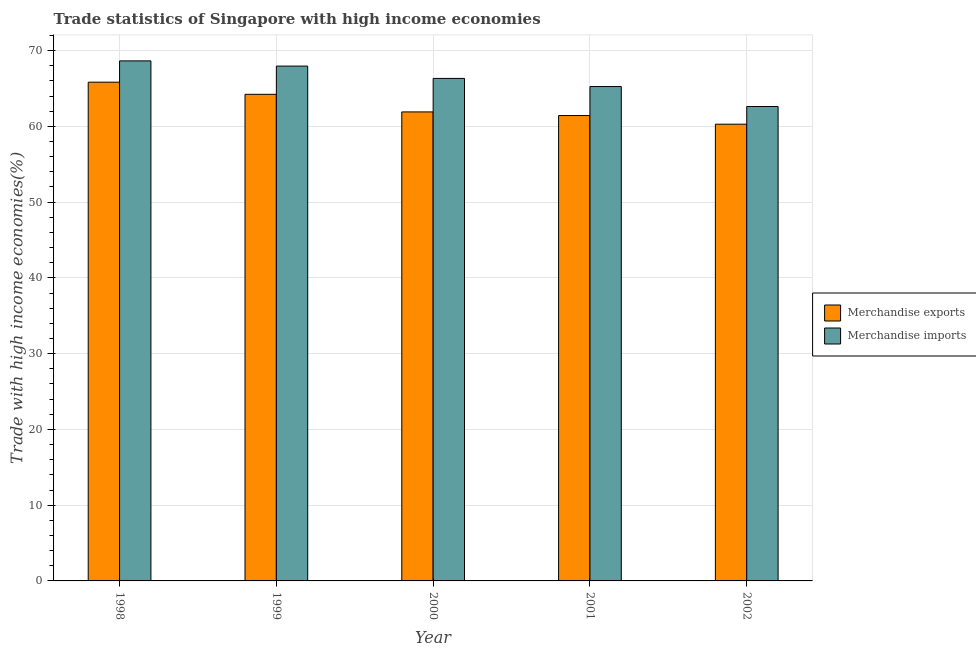How many different coloured bars are there?
Offer a terse response. 2. Are the number of bars on each tick of the X-axis equal?
Provide a succinct answer. Yes. How many bars are there on the 2nd tick from the left?
Your answer should be compact. 2. How many bars are there on the 2nd tick from the right?
Give a very brief answer. 2. In how many cases, is the number of bars for a given year not equal to the number of legend labels?
Offer a very short reply. 0. What is the merchandise imports in 2002?
Make the answer very short. 62.62. Across all years, what is the maximum merchandise exports?
Provide a short and direct response. 65.83. Across all years, what is the minimum merchandise exports?
Ensure brevity in your answer.  60.28. What is the total merchandise imports in the graph?
Offer a terse response. 330.78. What is the difference between the merchandise imports in 1998 and that in 2000?
Your response must be concise. 2.31. What is the difference between the merchandise imports in 2001 and the merchandise exports in 1998?
Offer a very short reply. -3.39. What is the average merchandise imports per year?
Offer a terse response. 66.16. What is the ratio of the merchandise exports in 1998 to that in 2000?
Provide a succinct answer. 1.06. Is the merchandise imports in 1999 less than that in 2001?
Provide a succinct answer. No. Is the difference between the merchandise exports in 1999 and 2001 greater than the difference between the merchandise imports in 1999 and 2001?
Provide a succinct answer. No. What is the difference between the highest and the second highest merchandise exports?
Offer a terse response. 1.6. What is the difference between the highest and the lowest merchandise imports?
Offer a very short reply. 6.02. In how many years, is the merchandise exports greater than the average merchandise exports taken over all years?
Offer a terse response. 2. Is the sum of the merchandise exports in 1998 and 2000 greater than the maximum merchandise imports across all years?
Keep it short and to the point. Yes. What does the 2nd bar from the left in 1999 represents?
Provide a succinct answer. Merchandise imports. What does the 1st bar from the right in 2000 represents?
Provide a short and direct response. Merchandise imports. How many bars are there?
Offer a very short reply. 10. Are all the bars in the graph horizontal?
Ensure brevity in your answer.  No. Does the graph contain any zero values?
Provide a short and direct response. No. Does the graph contain grids?
Provide a succinct answer. Yes. How are the legend labels stacked?
Offer a very short reply. Vertical. What is the title of the graph?
Give a very brief answer. Trade statistics of Singapore with high income economies. Does "Females" appear as one of the legend labels in the graph?
Give a very brief answer. No. What is the label or title of the Y-axis?
Make the answer very short. Trade with high income economies(%). What is the Trade with high income economies(%) in Merchandise exports in 1998?
Your response must be concise. 65.83. What is the Trade with high income economies(%) of Merchandise imports in 1998?
Your answer should be compact. 68.64. What is the Trade with high income economies(%) of Merchandise exports in 1999?
Offer a very short reply. 64.22. What is the Trade with high income economies(%) in Merchandise imports in 1999?
Offer a terse response. 67.95. What is the Trade with high income economies(%) of Merchandise exports in 2000?
Your answer should be compact. 61.9. What is the Trade with high income economies(%) of Merchandise imports in 2000?
Your answer should be very brief. 66.32. What is the Trade with high income economies(%) of Merchandise exports in 2001?
Offer a very short reply. 61.42. What is the Trade with high income economies(%) in Merchandise imports in 2001?
Ensure brevity in your answer.  65.25. What is the Trade with high income economies(%) in Merchandise exports in 2002?
Keep it short and to the point. 60.28. What is the Trade with high income economies(%) of Merchandise imports in 2002?
Offer a terse response. 62.62. Across all years, what is the maximum Trade with high income economies(%) in Merchandise exports?
Your response must be concise. 65.83. Across all years, what is the maximum Trade with high income economies(%) in Merchandise imports?
Provide a succinct answer. 68.64. Across all years, what is the minimum Trade with high income economies(%) of Merchandise exports?
Your answer should be compact. 60.28. Across all years, what is the minimum Trade with high income economies(%) of Merchandise imports?
Offer a terse response. 62.62. What is the total Trade with high income economies(%) in Merchandise exports in the graph?
Your answer should be compact. 313.65. What is the total Trade with high income economies(%) of Merchandise imports in the graph?
Your response must be concise. 330.78. What is the difference between the Trade with high income economies(%) in Merchandise exports in 1998 and that in 1999?
Give a very brief answer. 1.6. What is the difference between the Trade with high income economies(%) of Merchandise imports in 1998 and that in 1999?
Keep it short and to the point. 0.69. What is the difference between the Trade with high income economies(%) in Merchandise exports in 1998 and that in 2000?
Your answer should be compact. 3.93. What is the difference between the Trade with high income economies(%) of Merchandise imports in 1998 and that in 2000?
Ensure brevity in your answer.  2.31. What is the difference between the Trade with high income economies(%) in Merchandise exports in 1998 and that in 2001?
Make the answer very short. 4.41. What is the difference between the Trade with high income economies(%) of Merchandise imports in 1998 and that in 2001?
Ensure brevity in your answer.  3.39. What is the difference between the Trade with high income economies(%) in Merchandise exports in 1998 and that in 2002?
Offer a terse response. 5.55. What is the difference between the Trade with high income economies(%) in Merchandise imports in 1998 and that in 2002?
Your response must be concise. 6.02. What is the difference between the Trade with high income economies(%) of Merchandise exports in 1999 and that in 2000?
Your answer should be very brief. 2.32. What is the difference between the Trade with high income economies(%) of Merchandise imports in 1999 and that in 2000?
Your answer should be compact. 1.63. What is the difference between the Trade with high income economies(%) of Merchandise exports in 1999 and that in 2001?
Your response must be concise. 2.8. What is the difference between the Trade with high income economies(%) of Merchandise imports in 1999 and that in 2001?
Offer a very short reply. 2.7. What is the difference between the Trade with high income economies(%) in Merchandise exports in 1999 and that in 2002?
Your answer should be compact. 3.94. What is the difference between the Trade with high income economies(%) in Merchandise imports in 1999 and that in 2002?
Give a very brief answer. 5.33. What is the difference between the Trade with high income economies(%) in Merchandise exports in 2000 and that in 2001?
Ensure brevity in your answer.  0.48. What is the difference between the Trade with high income economies(%) of Merchandise imports in 2000 and that in 2001?
Keep it short and to the point. 1.07. What is the difference between the Trade with high income economies(%) in Merchandise exports in 2000 and that in 2002?
Make the answer very short. 1.62. What is the difference between the Trade with high income economies(%) in Merchandise imports in 2000 and that in 2002?
Provide a succinct answer. 3.71. What is the difference between the Trade with high income economies(%) in Merchandise exports in 2001 and that in 2002?
Make the answer very short. 1.14. What is the difference between the Trade with high income economies(%) of Merchandise imports in 2001 and that in 2002?
Ensure brevity in your answer.  2.63. What is the difference between the Trade with high income economies(%) in Merchandise exports in 1998 and the Trade with high income economies(%) in Merchandise imports in 1999?
Make the answer very short. -2.12. What is the difference between the Trade with high income economies(%) in Merchandise exports in 1998 and the Trade with high income economies(%) in Merchandise imports in 2000?
Keep it short and to the point. -0.5. What is the difference between the Trade with high income economies(%) of Merchandise exports in 1998 and the Trade with high income economies(%) of Merchandise imports in 2001?
Keep it short and to the point. 0.58. What is the difference between the Trade with high income economies(%) in Merchandise exports in 1998 and the Trade with high income economies(%) in Merchandise imports in 2002?
Make the answer very short. 3.21. What is the difference between the Trade with high income economies(%) in Merchandise exports in 1999 and the Trade with high income economies(%) in Merchandise imports in 2000?
Give a very brief answer. -2.1. What is the difference between the Trade with high income economies(%) in Merchandise exports in 1999 and the Trade with high income economies(%) in Merchandise imports in 2001?
Give a very brief answer. -1.03. What is the difference between the Trade with high income economies(%) of Merchandise exports in 1999 and the Trade with high income economies(%) of Merchandise imports in 2002?
Make the answer very short. 1.61. What is the difference between the Trade with high income economies(%) of Merchandise exports in 2000 and the Trade with high income economies(%) of Merchandise imports in 2001?
Make the answer very short. -3.35. What is the difference between the Trade with high income economies(%) of Merchandise exports in 2000 and the Trade with high income economies(%) of Merchandise imports in 2002?
Keep it short and to the point. -0.71. What is the difference between the Trade with high income economies(%) in Merchandise exports in 2001 and the Trade with high income economies(%) in Merchandise imports in 2002?
Your answer should be very brief. -1.19. What is the average Trade with high income economies(%) of Merchandise exports per year?
Provide a succinct answer. 62.73. What is the average Trade with high income economies(%) in Merchandise imports per year?
Your response must be concise. 66.16. In the year 1998, what is the difference between the Trade with high income economies(%) of Merchandise exports and Trade with high income economies(%) of Merchandise imports?
Make the answer very short. -2.81. In the year 1999, what is the difference between the Trade with high income economies(%) in Merchandise exports and Trade with high income economies(%) in Merchandise imports?
Provide a short and direct response. -3.73. In the year 2000, what is the difference between the Trade with high income economies(%) of Merchandise exports and Trade with high income economies(%) of Merchandise imports?
Ensure brevity in your answer.  -4.42. In the year 2001, what is the difference between the Trade with high income economies(%) of Merchandise exports and Trade with high income economies(%) of Merchandise imports?
Provide a succinct answer. -3.83. In the year 2002, what is the difference between the Trade with high income economies(%) of Merchandise exports and Trade with high income economies(%) of Merchandise imports?
Offer a terse response. -2.34. What is the ratio of the Trade with high income economies(%) of Merchandise exports in 1998 to that in 1999?
Keep it short and to the point. 1.02. What is the ratio of the Trade with high income economies(%) in Merchandise exports in 1998 to that in 2000?
Your answer should be very brief. 1.06. What is the ratio of the Trade with high income economies(%) of Merchandise imports in 1998 to that in 2000?
Provide a short and direct response. 1.03. What is the ratio of the Trade with high income economies(%) of Merchandise exports in 1998 to that in 2001?
Provide a short and direct response. 1.07. What is the ratio of the Trade with high income economies(%) in Merchandise imports in 1998 to that in 2001?
Ensure brevity in your answer.  1.05. What is the ratio of the Trade with high income economies(%) in Merchandise exports in 1998 to that in 2002?
Offer a very short reply. 1.09. What is the ratio of the Trade with high income economies(%) of Merchandise imports in 1998 to that in 2002?
Your response must be concise. 1.1. What is the ratio of the Trade with high income economies(%) in Merchandise exports in 1999 to that in 2000?
Your answer should be compact. 1.04. What is the ratio of the Trade with high income economies(%) in Merchandise imports in 1999 to that in 2000?
Make the answer very short. 1.02. What is the ratio of the Trade with high income economies(%) in Merchandise exports in 1999 to that in 2001?
Your answer should be very brief. 1.05. What is the ratio of the Trade with high income economies(%) of Merchandise imports in 1999 to that in 2001?
Keep it short and to the point. 1.04. What is the ratio of the Trade with high income economies(%) in Merchandise exports in 1999 to that in 2002?
Offer a very short reply. 1.07. What is the ratio of the Trade with high income economies(%) in Merchandise imports in 1999 to that in 2002?
Make the answer very short. 1.09. What is the ratio of the Trade with high income economies(%) of Merchandise imports in 2000 to that in 2001?
Provide a short and direct response. 1.02. What is the ratio of the Trade with high income economies(%) in Merchandise exports in 2000 to that in 2002?
Ensure brevity in your answer.  1.03. What is the ratio of the Trade with high income economies(%) in Merchandise imports in 2000 to that in 2002?
Offer a very short reply. 1.06. What is the ratio of the Trade with high income economies(%) in Merchandise exports in 2001 to that in 2002?
Keep it short and to the point. 1.02. What is the ratio of the Trade with high income economies(%) of Merchandise imports in 2001 to that in 2002?
Your answer should be compact. 1.04. What is the difference between the highest and the second highest Trade with high income economies(%) of Merchandise exports?
Make the answer very short. 1.6. What is the difference between the highest and the second highest Trade with high income economies(%) of Merchandise imports?
Keep it short and to the point. 0.69. What is the difference between the highest and the lowest Trade with high income economies(%) in Merchandise exports?
Provide a short and direct response. 5.55. What is the difference between the highest and the lowest Trade with high income economies(%) of Merchandise imports?
Your answer should be very brief. 6.02. 